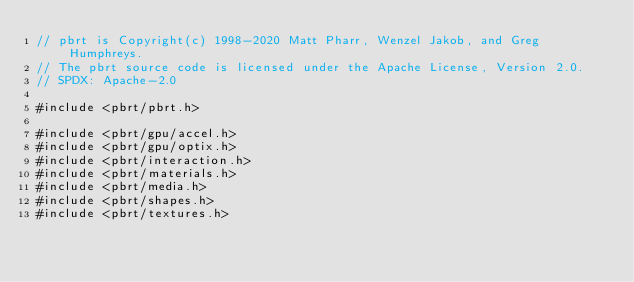<code> <loc_0><loc_0><loc_500><loc_500><_Cuda_>// pbrt is Copyright(c) 1998-2020 Matt Pharr, Wenzel Jakob, and Greg Humphreys.
// The pbrt source code is licensed under the Apache License, Version 2.0.
// SPDX: Apache-2.0

#include <pbrt/pbrt.h>

#include <pbrt/gpu/accel.h>
#include <pbrt/gpu/optix.h>
#include <pbrt/interaction.h>
#include <pbrt/materials.h>
#include <pbrt/media.h>
#include <pbrt/shapes.h>
#include <pbrt/textures.h></code> 